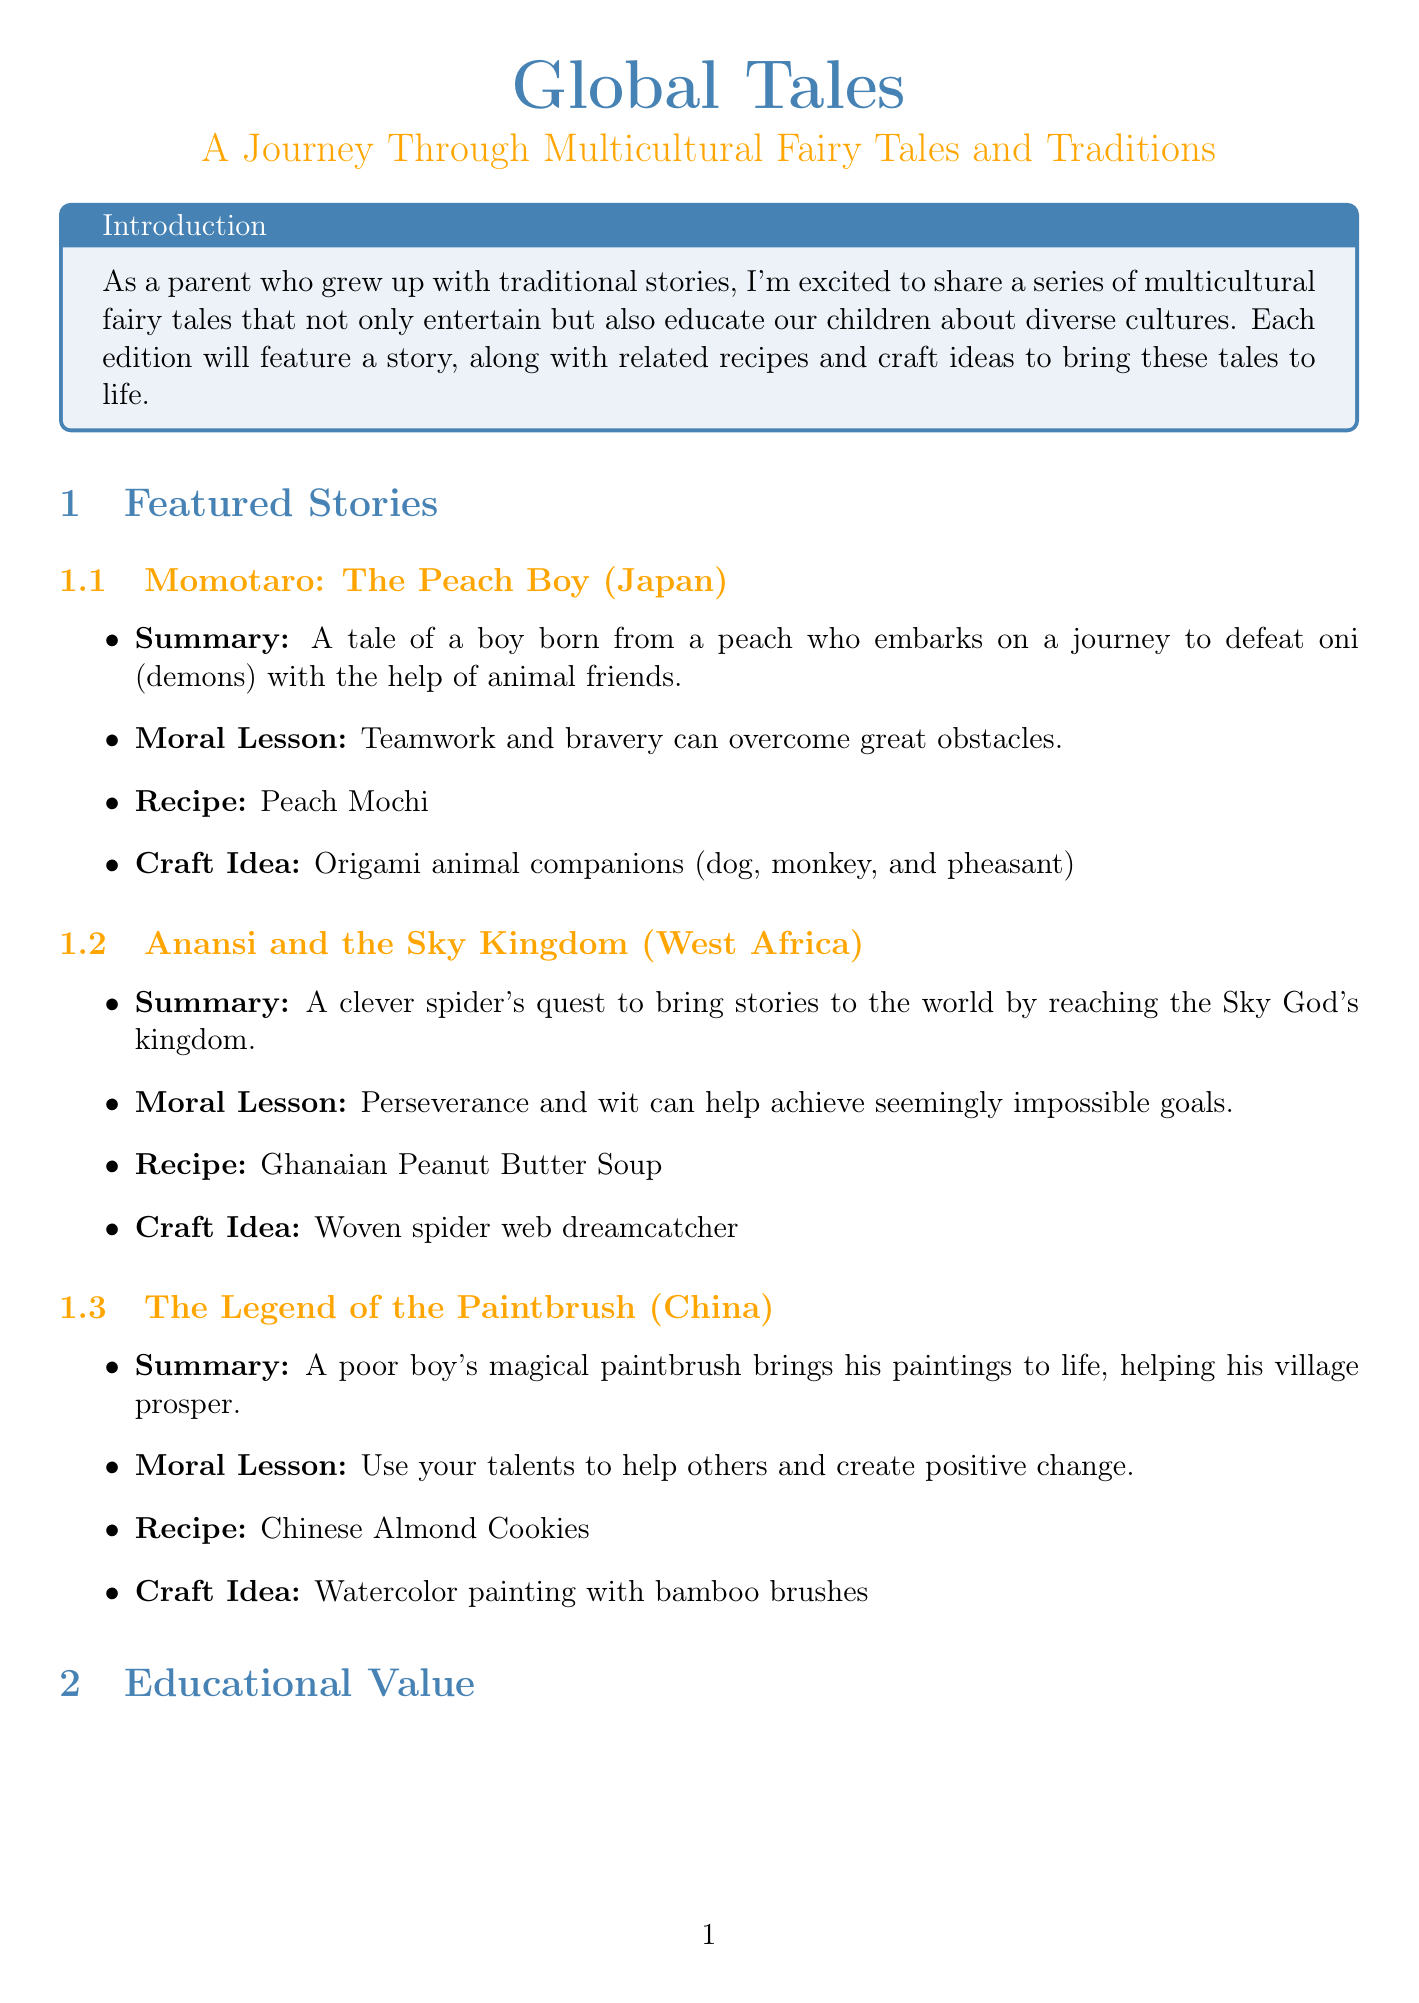What is the title of the newsletter? The title of the newsletter is stated at the beginning of the document.
Answer: Global Tales: A Journey Through Multicultural Fairy Tales and Traditions How many featured stories are there? The number of featured stories can be counted in the section that lists them.
Answer: 3 What is the origin of the story "Momotaro"? The origin of each story is mentioned right next to the story title.
Answer: Japan What moral lesson is conveyed in "Anansi and the Sky Kingdom"? The moral lessons are summarized under each story, providing insights into their thematic messages.
Answer: Perseverance and wit can help achieve seemingly impossible goals What is the craft idea associated with "The Legend of the Paintbrush"? Each story includes a related craft idea that enhances the educational experience.
Answer: Watercolor painting with bamboo brushes What resources are mentioned in the newsletter? Resources that provide additional educational materials are listed towards the end of the document.
Answer: International Children's Digital Library, Storytime Magazine, UNESCO Intangible Cultural Heritage How can parents encourage children to engage with the stories? The parenting tips section provides practical advice for parents in relation to the stories.
Answer: Discuss the cultural context of each story with your children What kind of contest is included in the reader engagement section? The document specifies activities for engaging readers, including contests.
Answer: Photo contest Which upcoming feature focuses specifically on folklore? The upcoming features include various topics, and one correlates to folklore.
Answer: European folklore and its influence on modern fantasy literature 